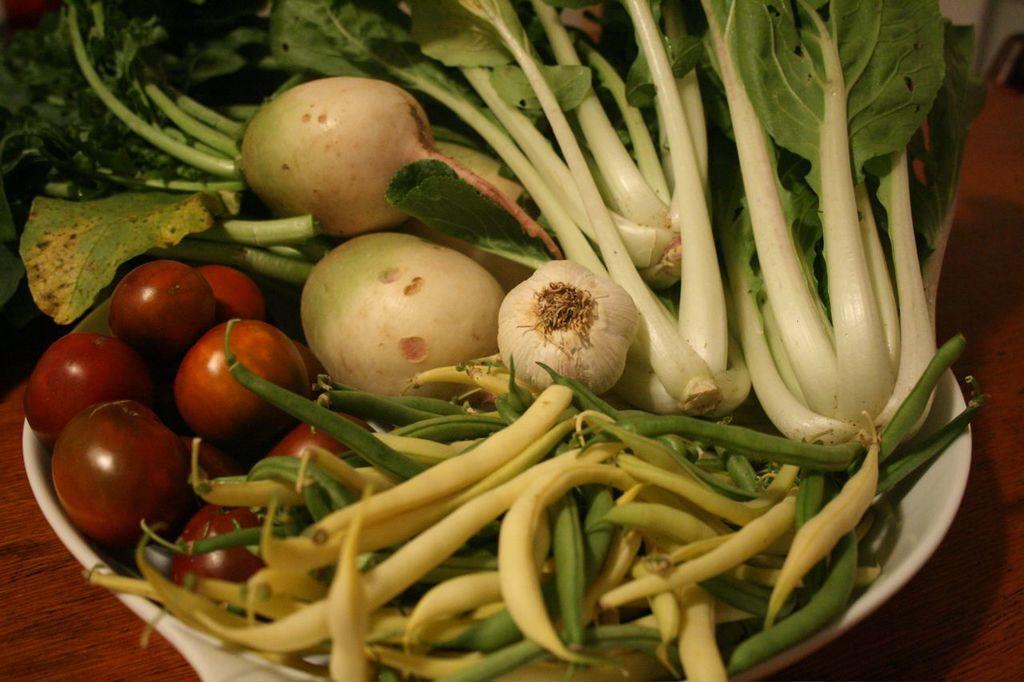Describe this image in one or two sentences. In this image I can see few vegetables, they are in red, green and white color in the bowl and the bowl is in white color. The bowl is on the table. 